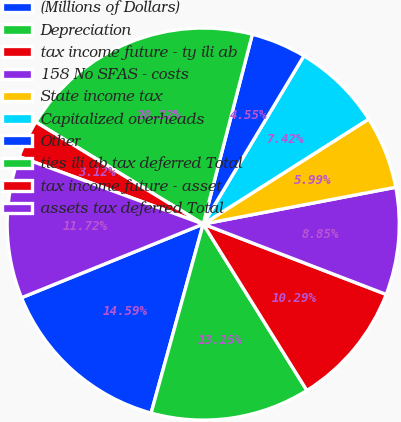Convert chart. <chart><loc_0><loc_0><loc_500><loc_500><pie_chart><fcel>(Millions of Dollars)<fcel>Depreciation<fcel>tax income future - ty ili ab<fcel>158 No SFAS - costs<fcel>State income tax<fcel>Capitalized overheads<fcel>Other<fcel>ties ili ab tax deferred Total<fcel>tax income future - asset<fcel>assets tax deferred Total<nl><fcel>14.59%<fcel>13.15%<fcel>10.29%<fcel>8.85%<fcel>5.99%<fcel>7.42%<fcel>4.55%<fcel>20.32%<fcel>3.12%<fcel>11.72%<nl></chart> 